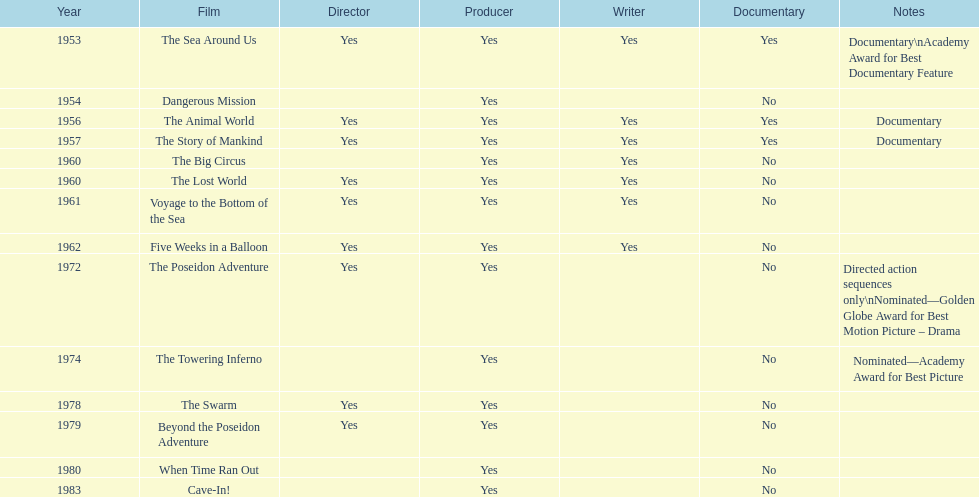How many films did irwin allen direct, produce and write? 6. 